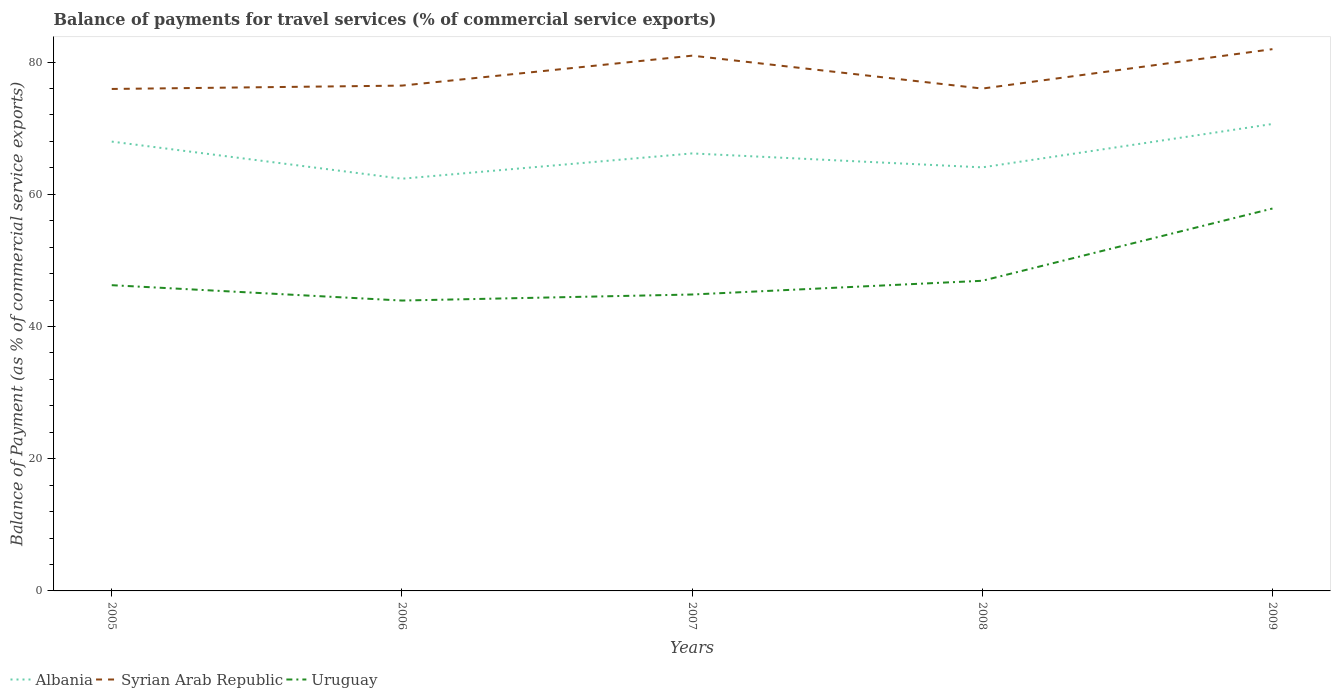How many different coloured lines are there?
Provide a succinct answer. 3. Across all years, what is the maximum balance of payments for travel services in Syrian Arab Republic?
Your response must be concise. 75.94. In which year was the balance of payments for travel services in Albania maximum?
Offer a very short reply. 2006. What is the total balance of payments for travel services in Uruguay in the graph?
Your answer should be very brief. -13.01. What is the difference between the highest and the second highest balance of payments for travel services in Syrian Arab Republic?
Your answer should be compact. 6.02. Is the balance of payments for travel services in Uruguay strictly greater than the balance of payments for travel services in Albania over the years?
Your response must be concise. Yes. Does the graph contain any zero values?
Make the answer very short. No. How many legend labels are there?
Offer a terse response. 3. What is the title of the graph?
Give a very brief answer. Balance of payments for travel services (% of commercial service exports). Does "Slovenia" appear as one of the legend labels in the graph?
Your response must be concise. No. What is the label or title of the X-axis?
Provide a succinct answer. Years. What is the label or title of the Y-axis?
Offer a terse response. Balance of Payment (as % of commercial service exports). What is the Balance of Payment (as % of commercial service exports) in Albania in 2005?
Provide a succinct answer. 67.97. What is the Balance of Payment (as % of commercial service exports) in Syrian Arab Republic in 2005?
Ensure brevity in your answer.  75.94. What is the Balance of Payment (as % of commercial service exports) in Uruguay in 2005?
Offer a very short reply. 46.25. What is the Balance of Payment (as % of commercial service exports) in Albania in 2006?
Give a very brief answer. 62.36. What is the Balance of Payment (as % of commercial service exports) in Syrian Arab Republic in 2006?
Give a very brief answer. 76.44. What is the Balance of Payment (as % of commercial service exports) of Uruguay in 2006?
Ensure brevity in your answer.  43.93. What is the Balance of Payment (as % of commercial service exports) in Albania in 2007?
Provide a succinct answer. 66.18. What is the Balance of Payment (as % of commercial service exports) in Syrian Arab Republic in 2007?
Your answer should be compact. 80.97. What is the Balance of Payment (as % of commercial service exports) in Uruguay in 2007?
Make the answer very short. 44.84. What is the Balance of Payment (as % of commercial service exports) in Albania in 2008?
Offer a terse response. 64.08. What is the Balance of Payment (as % of commercial service exports) of Syrian Arab Republic in 2008?
Your answer should be very brief. 75.99. What is the Balance of Payment (as % of commercial service exports) of Uruguay in 2008?
Ensure brevity in your answer.  46.92. What is the Balance of Payment (as % of commercial service exports) of Albania in 2009?
Your answer should be compact. 70.64. What is the Balance of Payment (as % of commercial service exports) of Syrian Arab Republic in 2009?
Give a very brief answer. 81.96. What is the Balance of Payment (as % of commercial service exports) in Uruguay in 2009?
Provide a succinct answer. 57.85. Across all years, what is the maximum Balance of Payment (as % of commercial service exports) in Albania?
Make the answer very short. 70.64. Across all years, what is the maximum Balance of Payment (as % of commercial service exports) in Syrian Arab Republic?
Offer a very short reply. 81.96. Across all years, what is the maximum Balance of Payment (as % of commercial service exports) in Uruguay?
Your answer should be compact. 57.85. Across all years, what is the minimum Balance of Payment (as % of commercial service exports) of Albania?
Keep it short and to the point. 62.36. Across all years, what is the minimum Balance of Payment (as % of commercial service exports) in Syrian Arab Republic?
Your answer should be compact. 75.94. Across all years, what is the minimum Balance of Payment (as % of commercial service exports) of Uruguay?
Provide a short and direct response. 43.93. What is the total Balance of Payment (as % of commercial service exports) of Albania in the graph?
Keep it short and to the point. 331.23. What is the total Balance of Payment (as % of commercial service exports) of Syrian Arab Republic in the graph?
Your response must be concise. 391.31. What is the total Balance of Payment (as % of commercial service exports) of Uruguay in the graph?
Make the answer very short. 239.79. What is the difference between the Balance of Payment (as % of commercial service exports) of Albania in 2005 and that in 2006?
Your response must be concise. 5.62. What is the difference between the Balance of Payment (as % of commercial service exports) of Syrian Arab Republic in 2005 and that in 2006?
Offer a very short reply. -0.51. What is the difference between the Balance of Payment (as % of commercial service exports) of Uruguay in 2005 and that in 2006?
Keep it short and to the point. 2.32. What is the difference between the Balance of Payment (as % of commercial service exports) of Albania in 2005 and that in 2007?
Offer a terse response. 1.79. What is the difference between the Balance of Payment (as % of commercial service exports) of Syrian Arab Republic in 2005 and that in 2007?
Ensure brevity in your answer.  -5.04. What is the difference between the Balance of Payment (as % of commercial service exports) of Uruguay in 2005 and that in 2007?
Ensure brevity in your answer.  1.41. What is the difference between the Balance of Payment (as % of commercial service exports) of Albania in 2005 and that in 2008?
Keep it short and to the point. 3.9. What is the difference between the Balance of Payment (as % of commercial service exports) of Syrian Arab Republic in 2005 and that in 2008?
Give a very brief answer. -0.06. What is the difference between the Balance of Payment (as % of commercial service exports) of Uruguay in 2005 and that in 2008?
Your answer should be very brief. -0.67. What is the difference between the Balance of Payment (as % of commercial service exports) in Albania in 2005 and that in 2009?
Your response must be concise. -2.66. What is the difference between the Balance of Payment (as % of commercial service exports) of Syrian Arab Republic in 2005 and that in 2009?
Your answer should be compact. -6.02. What is the difference between the Balance of Payment (as % of commercial service exports) in Uruguay in 2005 and that in 2009?
Your response must be concise. -11.6. What is the difference between the Balance of Payment (as % of commercial service exports) of Albania in 2006 and that in 2007?
Offer a terse response. -3.83. What is the difference between the Balance of Payment (as % of commercial service exports) of Syrian Arab Republic in 2006 and that in 2007?
Provide a succinct answer. -4.53. What is the difference between the Balance of Payment (as % of commercial service exports) of Uruguay in 2006 and that in 2007?
Give a very brief answer. -0.91. What is the difference between the Balance of Payment (as % of commercial service exports) in Albania in 2006 and that in 2008?
Your answer should be very brief. -1.72. What is the difference between the Balance of Payment (as % of commercial service exports) in Syrian Arab Republic in 2006 and that in 2008?
Ensure brevity in your answer.  0.45. What is the difference between the Balance of Payment (as % of commercial service exports) of Uruguay in 2006 and that in 2008?
Give a very brief answer. -2.99. What is the difference between the Balance of Payment (as % of commercial service exports) in Albania in 2006 and that in 2009?
Offer a terse response. -8.28. What is the difference between the Balance of Payment (as % of commercial service exports) of Syrian Arab Republic in 2006 and that in 2009?
Keep it short and to the point. -5.52. What is the difference between the Balance of Payment (as % of commercial service exports) of Uruguay in 2006 and that in 2009?
Keep it short and to the point. -13.92. What is the difference between the Balance of Payment (as % of commercial service exports) in Albania in 2007 and that in 2008?
Make the answer very short. 2.11. What is the difference between the Balance of Payment (as % of commercial service exports) of Syrian Arab Republic in 2007 and that in 2008?
Ensure brevity in your answer.  4.98. What is the difference between the Balance of Payment (as % of commercial service exports) in Uruguay in 2007 and that in 2008?
Your answer should be compact. -2.08. What is the difference between the Balance of Payment (as % of commercial service exports) of Albania in 2007 and that in 2009?
Offer a terse response. -4.45. What is the difference between the Balance of Payment (as % of commercial service exports) in Syrian Arab Republic in 2007 and that in 2009?
Your answer should be very brief. -0.99. What is the difference between the Balance of Payment (as % of commercial service exports) in Uruguay in 2007 and that in 2009?
Keep it short and to the point. -13.01. What is the difference between the Balance of Payment (as % of commercial service exports) of Albania in 2008 and that in 2009?
Your answer should be very brief. -6.56. What is the difference between the Balance of Payment (as % of commercial service exports) in Syrian Arab Republic in 2008 and that in 2009?
Give a very brief answer. -5.96. What is the difference between the Balance of Payment (as % of commercial service exports) of Uruguay in 2008 and that in 2009?
Keep it short and to the point. -10.93. What is the difference between the Balance of Payment (as % of commercial service exports) of Albania in 2005 and the Balance of Payment (as % of commercial service exports) of Syrian Arab Republic in 2006?
Ensure brevity in your answer.  -8.47. What is the difference between the Balance of Payment (as % of commercial service exports) in Albania in 2005 and the Balance of Payment (as % of commercial service exports) in Uruguay in 2006?
Your response must be concise. 24.05. What is the difference between the Balance of Payment (as % of commercial service exports) in Syrian Arab Republic in 2005 and the Balance of Payment (as % of commercial service exports) in Uruguay in 2006?
Your response must be concise. 32.01. What is the difference between the Balance of Payment (as % of commercial service exports) in Albania in 2005 and the Balance of Payment (as % of commercial service exports) in Syrian Arab Republic in 2007?
Make the answer very short. -13. What is the difference between the Balance of Payment (as % of commercial service exports) of Albania in 2005 and the Balance of Payment (as % of commercial service exports) of Uruguay in 2007?
Your answer should be very brief. 23.13. What is the difference between the Balance of Payment (as % of commercial service exports) in Syrian Arab Republic in 2005 and the Balance of Payment (as % of commercial service exports) in Uruguay in 2007?
Your answer should be compact. 31.1. What is the difference between the Balance of Payment (as % of commercial service exports) in Albania in 2005 and the Balance of Payment (as % of commercial service exports) in Syrian Arab Republic in 2008?
Your answer should be very brief. -8.02. What is the difference between the Balance of Payment (as % of commercial service exports) in Albania in 2005 and the Balance of Payment (as % of commercial service exports) in Uruguay in 2008?
Keep it short and to the point. 21.05. What is the difference between the Balance of Payment (as % of commercial service exports) of Syrian Arab Republic in 2005 and the Balance of Payment (as % of commercial service exports) of Uruguay in 2008?
Provide a short and direct response. 29.02. What is the difference between the Balance of Payment (as % of commercial service exports) of Albania in 2005 and the Balance of Payment (as % of commercial service exports) of Syrian Arab Republic in 2009?
Provide a succinct answer. -13.99. What is the difference between the Balance of Payment (as % of commercial service exports) of Albania in 2005 and the Balance of Payment (as % of commercial service exports) of Uruguay in 2009?
Provide a short and direct response. 10.12. What is the difference between the Balance of Payment (as % of commercial service exports) of Syrian Arab Republic in 2005 and the Balance of Payment (as % of commercial service exports) of Uruguay in 2009?
Your answer should be compact. 18.09. What is the difference between the Balance of Payment (as % of commercial service exports) of Albania in 2006 and the Balance of Payment (as % of commercial service exports) of Syrian Arab Republic in 2007?
Keep it short and to the point. -18.62. What is the difference between the Balance of Payment (as % of commercial service exports) in Albania in 2006 and the Balance of Payment (as % of commercial service exports) in Uruguay in 2007?
Your answer should be compact. 17.52. What is the difference between the Balance of Payment (as % of commercial service exports) of Syrian Arab Republic in 2006 and the Balance of Payment (as % of commercial service exports) of Uruguay in 2007?
Give a very brief answer. 31.6. What is the difference between the Balance of Payment (as % of commercial service exports) of Albania in 2006 and the Balance of Payment (as % of commercial service exports) of Syrian Arab Republic in 2008?
Offer a very short reply. -13.64. What is the difference between the Balance of Payment (as % of commercial service exports) in Albania in 2006 and the Balance of Payment (as % of commercial service exports) in Uruguay in 2008?
Ensure brevity in your answer.  15.44. What is the difference between the Balance of Payment (as % of commercial service exports) in Syrian Arab Republic in 2006 and the Balance of Payment (as % of commercial service exports) in Uruguay in 2008?
Offer a terse response. 29.52. What is the difference between the Balance of Payment (as % of commercial service exports) in Albania in 2006 and the Balance of Payment (as % of commercial service exports) in Syrian Arab Republic in 2009?
Keep it short and to the point. -19.6. What is the difference between the Balance of Payment (as % of commercial service exports) in Albania in 2006 and the Balance of Payment (as % of commercial service exports) in Uruguay in 2009?
Your answer should be very brief. 4.51. What is the difference between the Balance of Payment (as % of commercial service exports) of Syrian Arab Republic in 2006 and the Balance of Payment (as % of commercial service exports) of Uruguay in 2009?
Provide a succinct answer. 18.59. What is the difference between the Balance of Payment (as % of commercial service exports) in Albania in 2007 and the Balance of Payment (as % of commercial service exports) in Syrian Arab Republic in 2008?
Your answer should be very brief. -9.81. What is the difference between the Balance of Payment (as % of commercial service exports) of Albania in 2007 and the Balance of Payment (as % of commercial service exports) of Uruguay in 2008?
Your answer should be very brief. 19.27. What is the difference between the Balance of Payment (as % of commercial service exports) in Syrian Arab Republic in 2007 and the Balance of Payment (as % of commercial service exports) in Uruguay in 2008?
Provide a short and direct response. 34.05. What is the difference between the Balance of Payment (as % of commercial service exports) of Albania in 2007 and the Balance of Payment (as % of commercial service exports) of Syrian Arab Republic in 2009?
Your response must be concise. -15.77. What is the difference between the Balance of Payment (as % of commercial service exports) of Albania in 2007 and the Balance of Payment (as % of commercial service exports) of Uruguay in 2009?
Ensure brevity in your answer.  8.34. What is the difference between the Balance of Payment (as % of commercial service exports) of Syrian Arab Republic in 2007 and the Balance of Payment (as % of commercial service exports) of Uruguay in 2009?
Offer a very short reply. 23.12. What is the difference between the Balance of Payment (as % of commercial service exports) in Albania in 2008 and the Balance of Payment (as % of commercial service exports) in Syrian Arab Republic in 2009?
Offer a terse response. -17.88. What is the difference between the Balance of Payment (as % of commercial service exports) in Albania in 2008 and the Balance of Payment (as % of commercial service exports) in Uruguay in 2009?
Ensure brevity in your answer.  6.23. What is the difference between the Balance of Payment (as % of commercial service exports) of Syrian Arab Republic in 2008 and the Balance of Payment (as % of commercial service exports) of Uruguay in 2009?
Your answer should be compact. 18.15. What is the average Balance of Payment (as % of commercial service exports) of Albania per year?
Make the answer very short. 66.25. What is the average Balance of Payment (as % of commercial service exports) in Syrian Arab Republic per year?
Keep it short and to the point. 78.26. What is the average Balance of Payment (as % of commercial service exports) in Uruguay per year?
Provide a succinct answer. 47.96. In the year 2005, what is the difference between the Balance of Payment (as % of commercial service exports) in Albania and Balance of Payment (as % of commercial service exports) in Syrian Arab Republic?
Your response must be concise. -7.96. In the year 2005, what is the difference between the Balance of Payment (as % of commercial service exports) of Albania and Balance of Payment (as % of commercial service exports) of Uruguay?
Your response must be concise. 21.72. In the year 2005, what is the difference between the Balance of Payment (as % of commercial service exports) of Syrian Arab Republic and Balance of Payment (as % of commercial service exports) of Uruguay?
Provide a succinct answer. 29.69. In the year 2006, what is the difference between the Balance of Payment (as % of commercial service exports) in Albania and Balance of Payment (as % of commercial service exports) in Syrian Arab Republic?
Your response must be concise. -14.09. In the year 2006, what is the difference between the Balance of Payment (as % of commercial service exports) in Albania and Balance of Payment (as % of commercial service exports) in Uruguay?
Offer a terse response. 18.43. In the year 2006, what is the difference between the Balance of Payment (as % of commercial service exports) of Syrian Arab Republic and Balance of Payment (as % of commercial service exports) of Uruguay?
Make the answer very short. 32.52. In the year 2007, what is the difference between the Balance of Payment (as % of commercial service exports) of Albania and Balance of Payment (as % of commercial service exports) of Syrian Arab Republic?
Make the answer very short. -14.79. In the year 2007, what is the difference between the Balance of Payment (as % of commercial service exports) in Albania and Balance of Payment (as % of commercial service exports) in Uruguay?
Make the answer very short. 21.34. In the year 2007, what is the difference between the Balance of Payment (as % of commercial service exports) of Syrian Arab Republic and Balance of Payment (as % of commercial service exports) of Uruguay?
Your answer should be compact. 36.13. In the year 2008, what is the difference between the Balance of Payment (as % of commercial service exports) in Albania and Balance of Payment (as % of commercial service exports) in Syrian Arab Republic?
Offer a terse response. -11.92. In the year 2008, what is the difference between the Balance of Payment (as % of commercial service exports) of Albania and Balance of Payment (as % of commercial service exports) of Uruguay?
Ensure brevity in your answer.  17.16. In the year 2008, what is the difference between the Balance of Payment (as % of commercial service exports) in Syrian Arab Republic and Balance of Payment (as % of commercial service exports) in Uruguay?
Your response must be concise. 29.08. In the year 2009, what is the difference between the Balance of Payment (as % of commercial service exports) in Albania and Balance of Payment (as % of commercial service exports) in Syrian Arab Republic?
Your response must be concise. -11.32. In the year 2009, what is the difference between the Balance of Payment (as % of commercial service exports) in Albania and Balance of Payment (as % of commercial service exports) in Uruguay?
Your answer should be compact. 12.79. In the year 2009, what is the difference between the Balance of Payment (as % of commercial service exports) in Syrian Arab Republic and Balance of Payment (as % of commercial service exports) in Uruguay?
Your response must be concise. 24.11. What is the ratio of the Balance of Payment (as % of commercial service exports) in Albania in 2005 to that in 2006?
Offer a very short reply. 1.09. What is the ratio of the Balance of Payment (as % of commercial service exports) in Uruguay in 2005 to that in 2006?
Make the answer very short. 1.05. What is the ratio of the Balance of Payment (as % of commercial service exports) in Syrian Arab Republic in 2005 to that in 2007?
Your answer should be very brief. 0.94. What is the ratio of the Balance of Payment (as % of commercial service exports) of Uruguay in 2005 to that in 2007?
Your response must be concise. 1.03. What is the ratio of the Balance of Payment (as % of commercial service exports) of Albania in 2005 to that in 2008?
Provide a succinct answer. 1.06. What is the ratio of the Balance of Payment (as % of commercial service exports) in Syrian Arab Republic in 2005 to that in 2008?
Offer a very short reply. 1. What is the ratio of the Balance of Payment (as % of commercial service exports) of Uruguay in 2005 to that in 2008?
Your response must be concise. 0.99. What is the ratio of the Balance of Payment (as % of commercial service exports) in Albania in 2005 to that in 2009?
Your response must be concise. 0.96. What is the ratio of the Balance of Payment (as % of commercial service exports) in Syrian Arab Republic in 2005 to that in 2009?
Ensure brevity in your answer.  0.93. What is the ratio of the Balance of Payment (as % of commercial service exports) in Uruguay in 2005 to that in 2009?
Ensure brevity in your answer.  0.8. What is the ratio of the Balance of Payment (as % of commercial service exports) of Albania in 2006 to that in 2007?
Keep it short and to the point. 0.94. What is the ratio of the Balance of Payment (as % of commercial service exports) of Syrian Arab Republic in 2006 to that in 2007?
Offer a very short reply. 0.94. What is the ratio of the Balance of Payment (as % of commercial service exports) in Uruguay in 2006 to that in 2007?
Give a very brief answer. 0.98. What is the ratio of the Balance of Payment (as % of commercial service exports) in Albania in 2006 to that in 2008?
Provide a short and direct response. 0.97. What is the ratio of the Balance of Payment (as % of commercial service exports) of Syrian Arab Republic in 2006 to that in 2008?
Provide a succinct answer. 1.01. What is the ratio of the Balance of Payment (as % of commercial service exports) of Uruguay in 2006 to that in 2008?
Keep it short and to the point. 0.94. What is the ratio of the Balance of Payment (as % of commercial service exports) in Albania in 2006 to that in 2009?
Offer a terse response. 0.88. What is the ratio of the Balance of Payment (as % of commercial service exports) in Syrian Arab Republic in 2006 to that in 2009?
Your answer should be very brief. 0.93. What is the ratio of the Balance of Payment (as % of commercial service exports) in Uruguay in 2006 to that in 2009?
Offer a very short reply. 0.76. What is the ratio of the Balance of Payment (as % of commercial service exports) in Albania in 2007 to that in 2008?
Ensure brevity in your answer.  1.03. What is the ratio of the Balance of Payment (as % of commercial service exports) of Syrian Arab Republic in 2007 to that in 2008?
Provide a short and direct response. 1.07. What is the ratio of the Balance of Payment (as % of commercial service exports) in Uruguay in 2007 to that in 2008?
Offer a very short reply. 0.96. What is the ratio of the Balance of Payment (as % of commercial service exports) of Albania in 2007 to that in 2009?
Your response must be concise. 0.94. What is the ratio of the Balance of Payment (as % of commercial service exports) of Uruguay in 2007 to that in 2009?
Keep it short and to the point. 0.78. What is the ratio of the Balance of Payment (as % of commercial service exports) of Albania in 2008 to that in 2009?
Provide a short and direct response. 0.91. What is the ratio of the Balance of Payment (as % of commercial service exports) of Syrian Arab Republic in 2008 to that in 2009?
Offer a terse response. 0.93. What is the ratio of the Balance of Payment (as % of commercial service exports) in Uruguay in 2008 to that in 2009?
Make the answer very short. 0.81. What is the difference between the highest and the second highest Balance of Payment (as % of commercial service exports) in Albania?
Your answer should be compact. 2.66. What is the difference between the highest and the second highest Balance of Payment (as % of commercial service exports) of Syrian Arab Republic?
Your response must be concise. 0.99. What is the difference between the highest and the second highest Balance of Payment (as % of commercial service exports) in Uruguay?
Keep it short and to the point. 10.93. What is the difference between the highest and the lowest Balance of Payment (as % of commercial service exports) in Albania?
Your response must be concise. 8.28. What is the difference between the highest and the lowest Balance of Payment (as % of commercial service exports) of Syrian Arab Republic?
Offer a terse response. 6.02. What is the difference between the highest and the lowest Balance of Payment (as % of commercial service exports) in Uruguay?
Your response must be concise. 13.92. 